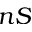<formula> <loc_0><loc_0><loc_500><loc_500>n S</formula> 